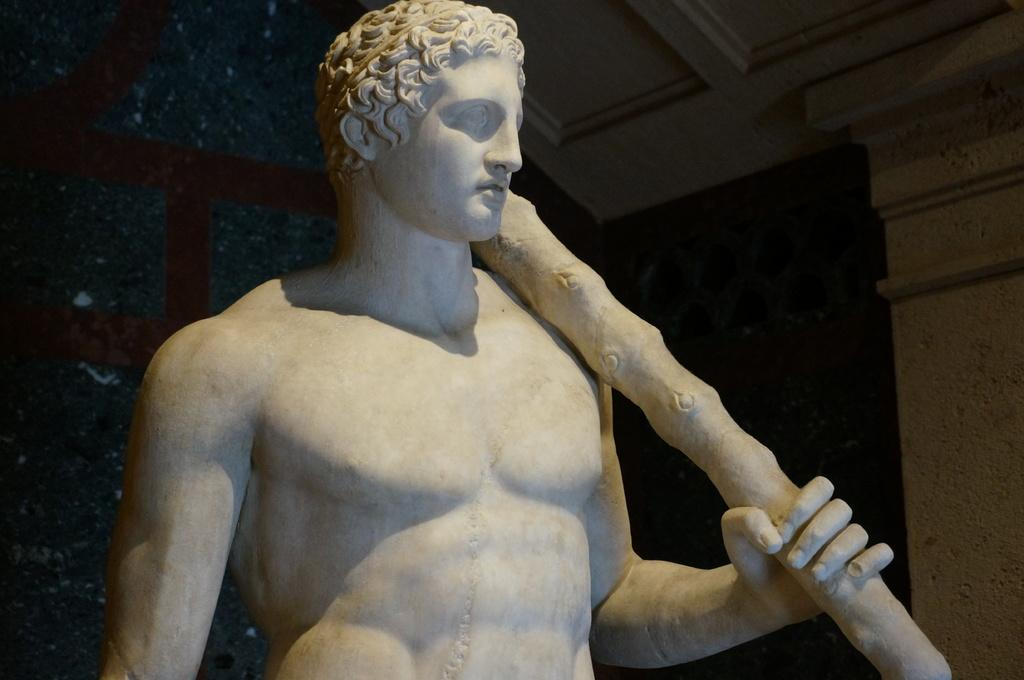What is the main subject in the center of the image? There is a person's statue in the center of the image. What other architectural element can be seen in the image? There is a pillar in the image. What part of the building is visible in the image? The ceiling is visible in the image. How many lizards are crawling on the statue in the image? There are no lizards present in the image; it only features a person's statue, a pillar, and the ceiling. 